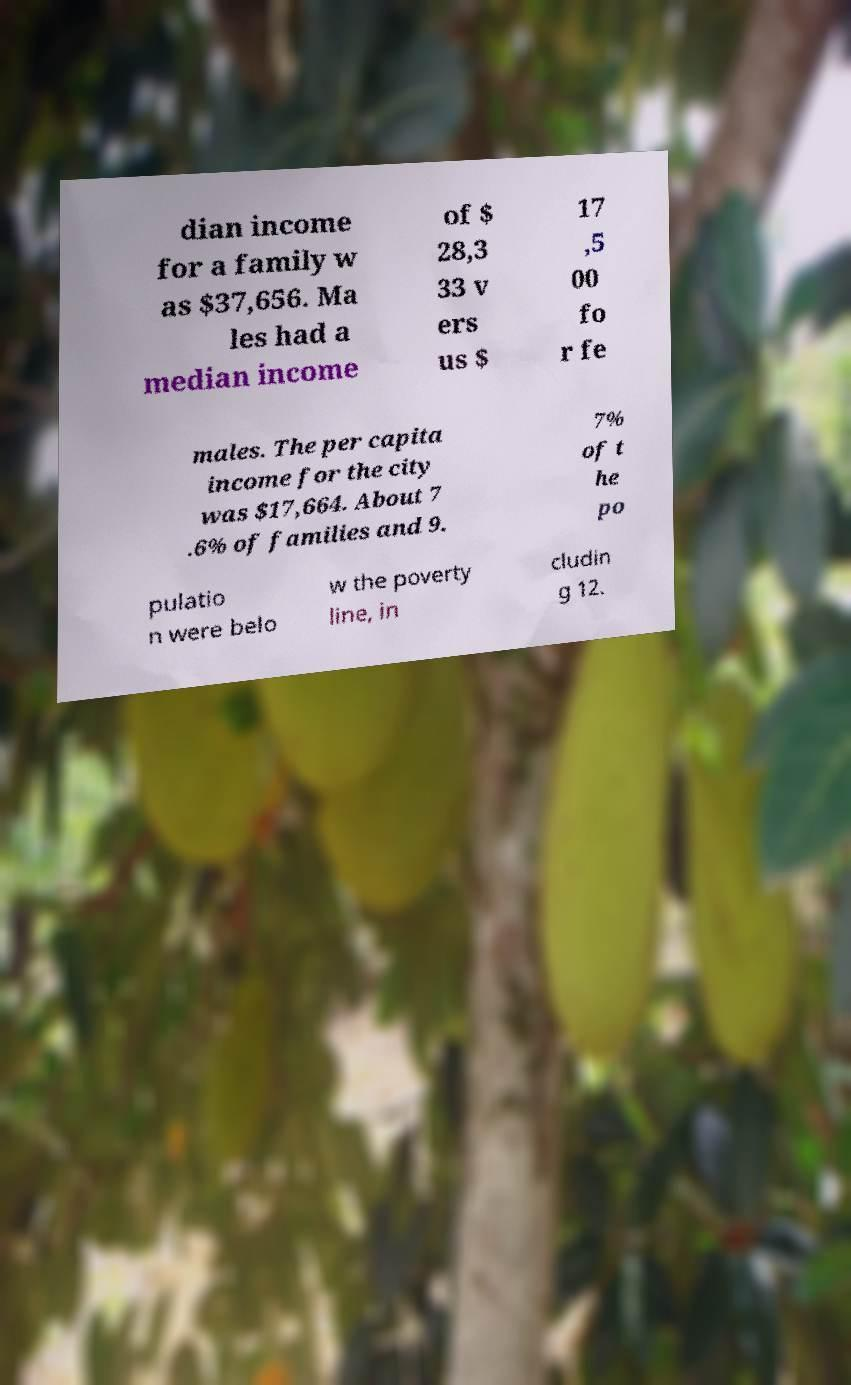Could you assist in decoding the text presented in this image and type it out clearly? dian income for a family w as $37,656. Ma les had a median income of $ 28,3 33 v ers us $ 17 ,5 00 fo r fe males. The per capita income for the city was $17,664. About 7 .6% of families and 9. 7% of t he po pulatio n were belo w the poverty line, in cludin g 12. 